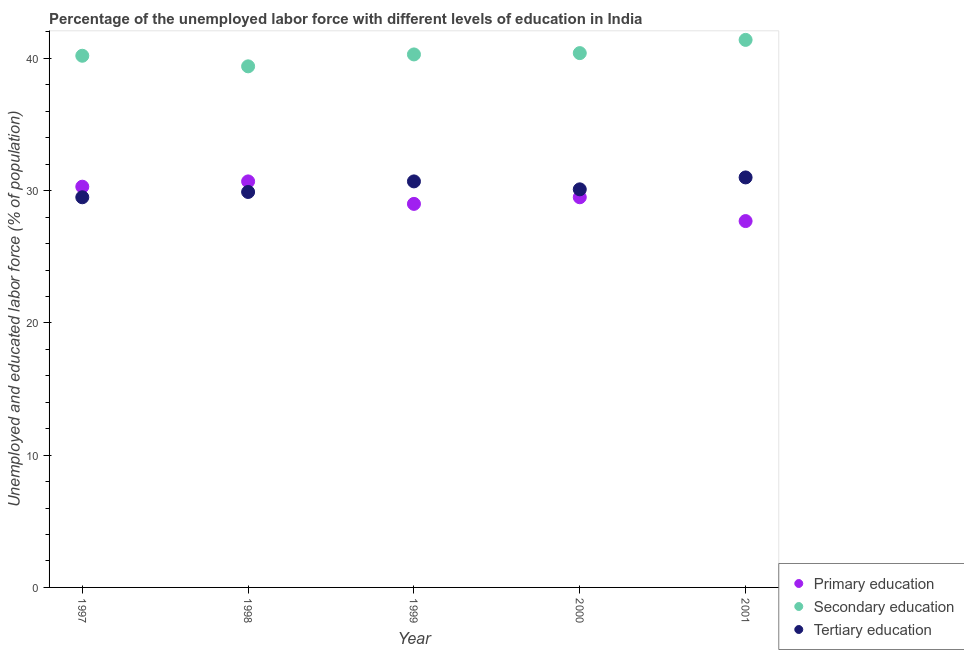How many different coloured dotlines are there?
Your answer should be very brief. 3. Across all years, what is the maximum percentage of labor force who received primary education?
Keep it short and to the point. 30.7. Across all years, what is the minimum percentage of labor force who received secondary education?
Offer a terse response. 39.4. In which year was the percentage of labor force who received tertiary education minimum?
Give a very brief answer. 1997. What is the total percentage of labor force who received tertiary education in the graph?
Your answer should be very brief. 151.2. What is the difference between the percentage of labor force who received primary education in 2000 and that in 2001?
Offer a very short reply. 1.8. What is the difference between the percentage of labor force who received tertiary education in 1998 and the percentage of labor force who received secondary education in 2000?
Your answer should be compact. -10.5. What is the average percentage of labor force who received secondary education per year?
Provide a short and direct response. 40.34. In the year 1998, what is the difference between the percentage of labor force who received tertiary education and percentage of labor force who received secondary education?
Your answer should be compact. -9.5. In how many years, is the percentage of labor force who received primary education greater than 40 %?
Provide a short and direct response. 0. What is the ratio of the percentage of labor force who received tertiary education in 1998 to that in 2000?
Provide a short and direct response. 0.99. Is the percentage of labor force who received primary education in 1997 less than that in 2001?
Offer a terse response. No. What is the difference between the highest and the second highest percentage of labor force who received primary education?
Ensure brevity in your answer.  0.4. What is the difference between the highest and the lowest percentage of labor force who received tertiary education?
Ensure brevity in your answer.  1.5. Is the sum of the percentage of labor force who received tertiary education in 1997 and 1999 greater than the maximum percentage of labor force who received secondary education across all years?
Give a very brief answer. Yes. Is it the case that in every year, the sum of the percentage of labor force who received primary education and percentage of labor force who received secondary education is greater than the percentage of labor force who received tertiary education?
Give a very brief answer. Yes. Does the percentage of labor force who received tertiary education monotonically increase over the years?
Give a very brief answer. No. Is the percentage of labor force who received secondary education strictly less than the percentage of labor force who received primary education over the years?
Your answer should be very brief. No. Are the values on the major ticks of Y-axis written in scientific E-notation?
Your response must be concise. No. Where does the legend appear in the graph?
Your answer should be compact. Bottom right. What is the title of the graph?
Your answer should be compact. Percentage of the unemployed labor force with different levels of education in India. Does "Grants" appear as one of the legend labels in the graph?
Make the answer very short. No. What is the label or title of the Y-axis?
Provide a short and direct response. Unemployed and educated labor force (% of population). What is the Unemployed and educated labor force (% of population) in Primary education in 1997?
Ensure brevity in your answer.  30.3. What is the Unemployed and educated labor force (% of population) in Secondary education in 1997?
Ensure brevity in your answer.  40.2. What is the Unemployed and educated labor force (% of population) of Tertiary education in 1997?
Offer a terse response. 29.5. What is the Unemployed and educated labor force (% of population) in Primary education in 1998?
Provide a short and direct response. 30.7. What is the Unemployed and educated labor force (% of population) in Secondary education in 1998?
Your answer should be very brief. 39.4. What is the Unemployed and educated labor force (% of population) in Tertiary education in 1998?
Offer a very short reply. 29.9. What is the Unemployed and educated labor force (% of population) in Secondary education in 1999?
Keep it short and to the point. 40.3. What is the Unemployed and educated labor force (% of population) of Tertiary education in 1999?
Your answer should be very brief. 30.7. What is the Unemployed and educated labor force (% of population) in Primary education in 2000?
Provide a short and direct response. 29.5. What is the Unemployed and educated labor force (% of population) in Secondary education in 2000?
Keep it short and to the point. 40.4. What is the Unemployed and educated labor force (% of population) of Tertiary education in 2000?
Ensure brevity in your answer.  30.1. What is the Unemployed and educated labor force (% of population) in Primary education in 2001?
Offer a very short reply. 27.7. What is the Unemployed and educated labor force (% of population) in Secondary education in 2001?
Ensure brevity in your answer.  41.4. Across all years, what is the maximum Unemployed and educated labor force (% of population) in Primary education?
Provide a short and direct response. 30.7. Across all years, what is the maximum Unemployed and educated labor force (% of population) of Secondary education?
Provide a succinct answer. 41.4. Across all years, what is the minimum Unemployed and educated labor force (% of population) in Primary education?
Keep it short and to the point. 27.7. Across all years, what is the minimum Unemployed and educated labor force (% of population) in Secondary education?
Your answer should be compact. 39.4. Across all years, what is the minimum Unemployed and educated labor force (% of population) of Tertiary education?
Give a very brief answer. 29.5. What is the total Unemployed and educated labor force (% of population) in Primary education in the graph?
Ensure brevity in your answer.  147.2. What is the total Unemployed and educated labor force (% of population) of Secondary education in the graph?
Provide a succinct answer. 201.7. What is the total Unemployed and educated labor force (% of population) of Tertiary education in the graph?
Make the answer very short. 151.2. What is the difference between the Unemployed and educated labor force (% of population) of Primary education in 1997 and that in 1998?
Your answer should be very brief. -0.4. What is the difference between the Unemployed and educated labor force (% of population) in Primary education in 1997 and that in 2000?
Provide a succinct answer. 0.8. What is the difference between the Unemployed and educated labor force (% of population) in Tertiary education in 1997 and that in 2000?
Provide a short and direct response. -0.6. What is the difference between the Unemployed and educated labor force (% of population) in Tertiary education in 1997 and that in 2001?
Provide a succinct answer. -1.5. What is the difference between the Unemployed and educated labor force (% of population) of Primary education in 1998 and that in 2000?
Your answer should be very brief. 1.2. What is the difference between the Unemployed and educated labor force (% of population) of Secondary education in 1998 and that in 2000?
Your answer should be compact. -1. What is the difference between the Unemployed and educated labor force (% of population) in Tertiary education in 1998 and that in 2000?
Your answer should be very brief. -0.2. What is the difference between the Unemployed and educated labor force (% of population) of Secondary education in 1999 and that in 2000?
Provide a succinct answer. -0.1. What is the difference between the Unemployed and educated labor force (% of population) in Tertiary education in 1999 and that in 2000?
Make the answer very short. 0.6. What is the difference between the Unemployed and educated labor force (% of population) in Primary education in 1999 and that in 2001?
Ensure brevity in your answer.  1.3. What is the difference between the Unemployed and educated labor force (% of population) in Secondary education in 1999 and that in 2001?
Offer a very short reply. -1.1. What is the difference between the Unemployed and educated labor force (% of population) in Tertiary education in 1999 and that in 2001?
Provide a succinct answer. -0.3. What is the difference between the Unemployed and educated labor force (% of population) of Primary education in 2000 and that in 2001?
Offer a terse response. 1.8. What is the difference between the Unemployed and educated labor force (% of population) in Secondary education in 2000 and that in 2001?
Your response must be concise. -1. What is the difference between the Unemployed and educated labor force (% of population) in Primary education in 1997 and the Unemployed and educated labor force (% of population) in Secondary education in 1999?
Keep it short and to the point. -10. What is the difference between the Unemployed and educated labor force (% of population) of Primary education in 1997 and the Unemployed and educated labor force (% of population) of Secondary education in 2000?
Your answer should be very brief. -10.1. What is the difference between the Unemployed and educated labor force (% of population) in Primary education in 1997 and the Unemployed and educated labor force (% of population) in Tertiary education in 2000?
Your answer should be very brief. 0.2. What is the difference between the Unemployed and educated labor force (% of population) in Secondary education in 1997 and the Unemployed and educated labor force (% of population) in Tertiary education in 2000?
Ensure brevity in your answer.  10.1. What is the difference between the Unemployed and educated labor force (% of population) in Primary education in 1997 and the Unemployed and educated labor force (% of population) in Tertiary education in 2001?
Offer a terse response. -0.7. What is the difference between the Unemployed and educated labor force (% of population) in Secondary education in 1997 and the Unemployed and educated labor force (% of population) in Tertiary education in 2001?
Offer a terse response. 9.2. What is the difference between the Unemployed and educated labor force (% of population) of Primary education in 1998 and the Unemployed and educated labor force (% of population) of Tertiary education in 1999?
Provide a short and direct response. 0. What is the difference between the Unemployed and educated labor force (% of population) in Secondary education in 1998 and the Unemployed and educated labor force (% of population) in Tertiary education in 1999?
Your answer should be very brief. 8.7. What is the difference between the Unemployed and educated labor force (% of population) in Primary education in 1998 and the Unemployed and educated labor force (% of population) in Tertiary education in 2000?
Give a very brief answer. 0.6. What is the difference between the Unemployed and educated labor force (% of population) in Secondary education in 1998 and the Unemployed and educated labor force (% of population) in Tertiary education in 2000?
Provide a short and direct response. 9.3. What is the difference between the Unemployed and educated labor force (% of population) of Primary education in 1998 and the Unemployed and educated labor force (% of population) of Tertiary education in 2001?
Your answer should be compact. -0.3. What is the difference between the Unemployed and educated labor force (% of population) in Secondary education in 1998 and the Unemployed and educated labor force (% of population) in Tertiary education in 2001?
Keep it short and to the point. 8.4. What is the difference between the Unemployed and educated labor force (% of population) of Primary education in 1999 and the Unemployed and educated labor force (% of population) of Tertiary education in 2000?
Provide a short and direct response. -1.1. What is the difference between the Unemployed and educated labor force (% of population) in Secondary education in 1999 and the Unemployed and educated labor force (% of population) in Tertiary education in 2001?
Provide a succinct answer. 9.3. What is the difference between the Unemployed and educated labor force (% of population) in Primary education in 2000 and the Unemployed and educated labor force (% of population) in Tertiary education in 2001?
Provide a succinct answer. -1.5. What is the difference between the Unemployed and educated labor force (% of population) in Secondary education in 2000 and the Unemployed and educated labor force (% of population) in Tertiary education in 2001?
Make the answer very short. 9.4. What is the average Unemployed and educated labor force (% of population) in Primary education per year?
Offer a very short reply. 29.44. What is the average Unemployed and educated labor force (% of population) in Secondary education per year?
Offer a very short reply. 40.34. What is the average Unemployed and educated labor force (% of population) of Tertiary education per year?
Offer a terse response. 30.24. In the year 1997, what is the difference between the Unemployed and educated labor force (% of population) in Primary education and Unemployed and educated labor force (% of population) in Tertiary education?
Give a very brief answer. 0.8. In the year 1998, what is the difference between the Unemployed and educated labor force (% of population) of Primary education and Unemployed and educated labor force (% of population) of Secondary education?
Make the answer very short. -8.7. In the year 1998, what is the difference between the Unemployed and educated labor force (% of population) of Primary education and Unemployed and educated labor force (% of population) of Tertiary education?
Your answer should be very brief. 0.8. In the year 2000, what is the difference between the Unemployed and educated labor force (% of population) in Primary education and Unemployed and educated labor force (% of population) in Tertiary education?
Give a very brief answer. -0.6. In the year 2000, what is the difference between the Unemployed and educated labor force (% of population) of Secondary education and Unemployed and educated labor force (% of population) of Tertiary education?
Keep it short and to the point. 10.3. In the year 2001, what is the difference between the Unemployed and educated labor force (% of population) in Primary education and Unemployed and educated labor force (% of population) in Secondary education?
Your response must be concise. -13.7. In the year 2001, what is the difference between the Unemployed and educated labor force (% of population) in Secondary education and Unemployed and educated labor force (% of population) in Tertiary education?
Provide a succinct answer. 10.4. What is the ratio of the Unemployed and educated labor force (% of population) in Secondary education in 1997 to that in 1998?
Your answer should be very brief. 1.02. What is the ratio of the Unemployed and educated labor force (% of population) in Tertiary education in 1997 to that in 1998?
Your response must be concise. 0.99. What is the ratio of the Unemployed and educated labor force (% of population) in Primary education in 1997 to that in 1999?
Make the answer very short. 1.04. What is the ratio of the Unemployed and educated labor force (% of population) of Tertiary education in 1997 to that in 1999?
Your response must be concise. 0.96. What is the ratio of the Unemployed and educated labor force (% of population) of Primary education in 1997 to that in 2000?
Give a very brief answer. 1.03. What is the ratio of the Unemployed and educated labor force (% of population) in Tertiary education in 1997 to that in 2000?
Ensure brevity in your answer.  0.98. What is the ratio of the Unemployed and educated labor force (% of population) of Primary education in 1997 to that in 2001?
Provide a short and direct response. 1.09. What is the ratio of the Unemployed and educated labor force (% of population) of Secondary education in 1997 to that in 2001?
Keep it short and to the point. 0.97. What is the ratio of the Unemployed and educated labor force (% of population) in Tertiary education in 1997 to that in 2001?
Your answer should be compact. 0.95. What is the ratio of the Unemployed and educated labor force (% of population) of Primary education in 1998 to that in 1999?
Your response must be concise. 1.06. What is the ratio of the Unemployed and educated labor force (% of population) of Secondary education in 1998 to that in 1999?
Your answer should be very brief. 0.98. What is the ratio of the Unemployed and educated labor force (% of population) in Tertiary education in 1998 to that in 1999?
Make the answer very short. 0.97. What is the ratio of the Unemployed and educated labor force (% of population) of Primary education in 1998 to that in 2000?
Offer a terse response. 1.04. What is the ratio of the Unemployed and educated labor force (% of population) in Secondary education in 1998 to that in 2000?
Offer a very short reply. 0.98. What is the ratio of the Unemployed and educated labor force (% of population) of Tertiary education in 1998 to that in 2000?
Your response must be concise. 0.99. What is the ratio of the Unemployed and educated labor force (% of population) in Primary education in 1998 to that in 2001?
Your answer should be very brief. 1.11. What is the ratio of the Unemployed and educated labor force (% of population) in Secondary education in 1998 to that in 2001?
Your answer should be compact. 0.95. What is the ratio of the Unemployed and educated labor force (% of population) in Tertiary education in 1998 to that in 2001?
Keep it short and to the point. 0.96. What is the ratio of the Unemployed and educated labor force (% of population) in Primary education in 1999 to that in 2000?
Your answer should be compact. 0.98. What is the ratio of the Unemployed and educated labor force (% of population) of Secondary education in 1999 to that in 2000?
Offer a very short reply. 1. What is the ratio of the Unemployed and educated labor force (% of population) in Tertiary education in 1999 to that in 2000?
Ensure brevity in your answer.  1.02. What is the ratio of the Unemployed and educated labor force (% of population) in Primary education in 1999 to that in 2001?
Give a very brief answer. 1.05. What is the ratio of the Unemployed and educated labor force (% of population) of Secondary education in 1999 to that in 2001?
Provide a short and direct response. 0.97. What is the ratio of the Unemployed and educated labor force (% of population) in Tertiary education in 1999 to that in 2001?
Keep it short and to the point. 0.99. What is the ratio of the Unemployed and educated labor force (% of population) of Primary education in 2000 to that in 2001?
Your answer should be very brief. 1.06. What is the ratio of the Unemployed and educated labor force (% of population) of Secondary education in 2000 to that in 2001?
Your response must be concise. 0.98. What is the ratio of the Unemployed and educated labor force (% of population) of Tertiary education in 2000 to that in 2001?
Your response must be concise. 0.97. What is the difference between the highest and the second highest Unemployed and educated labor force (% of population) of Primary education?
Your answer should be compact. 0.4. What is the difference between the highest and the second highest Unemployed and educated labor force (% of population) of Tertiary education?
Give a very brief answer. 0.3. 